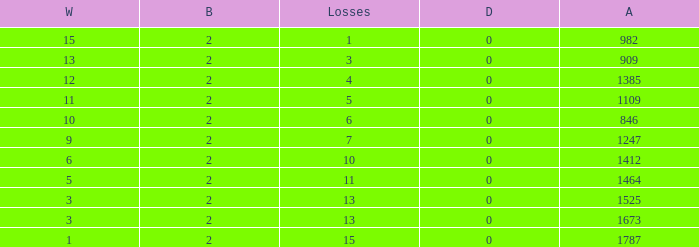What is the average number of Byes when there were less than 0 losses and were against 1247? None. 